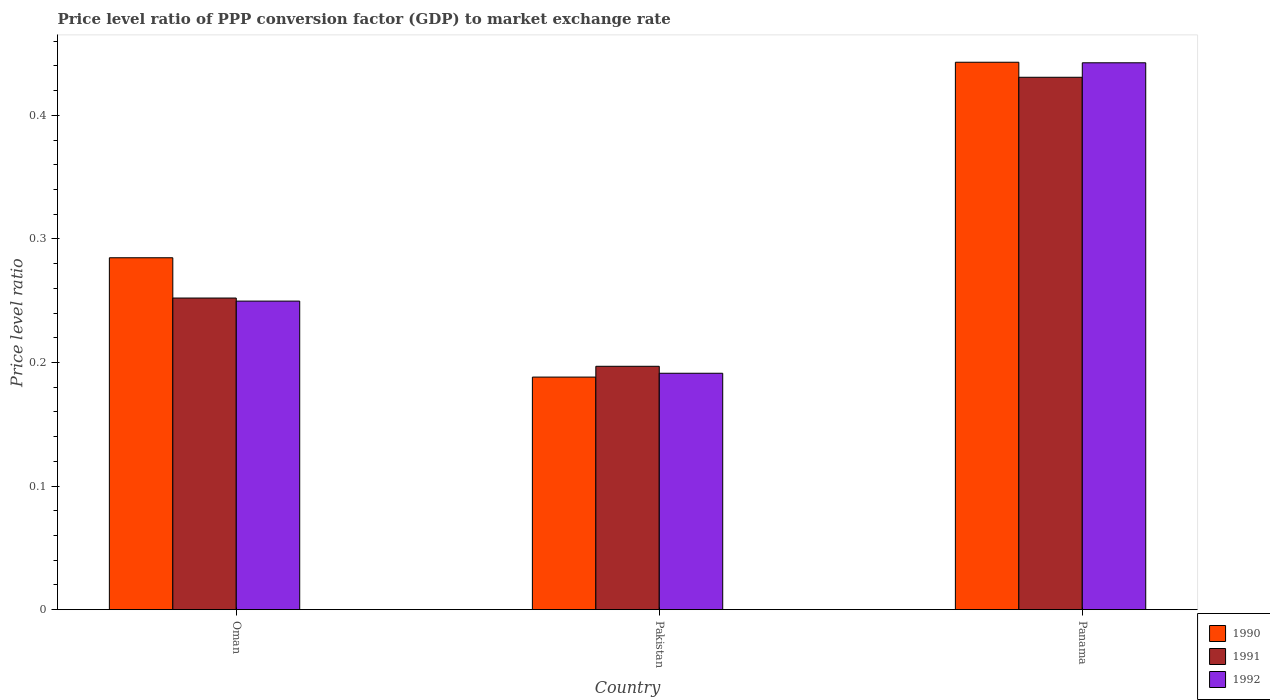How many different coloured bars are there?
Provide a short and direct response. 3. Are the number of bars per tick equal to the number of legend labels?
Make the answer very short. Yes. Are the number of bars on each tick of the X-axis equal?
Give a very brief answer. Yes. What is the label of the 2nd group of bars from the left?
Provide a short and direct response. Pakistan. What is the price level ratio in 1991 in Oman?
Your response must be concise. 0.25. Across all countries, what is the maximum price level ratio in 1992?
Your answer should be very brief. 0.44. Across all countries, what is the minimum price level ratio in 1990?
Make the answer very short. 0.19. In which country was the price level ratio in 1991 maximum?
Your answer should be compact. Panama. In which country was the price level ratio in 1990 minimum?
Provide a succinct answer. Pakistan. What is the total price level ratio in 1992 in the graph?
Offer a terse response. 0.88. What is the difference between the price level ratio in 1991 in Oman and that in Panama?
Your answer should be compact. -0.18. What is the difference between the price level ratio in 1990 in Oman and the price level ratio in 1992 in Pakistan?
Provide a short and direct response. 0.09. What is the average price level ratio in 1992 per country?
Your answer should be very brief. 0.29. What is the difference between the price level ratio of/in 1991 and price level ratio of/in 1990 in Panama?
Keep it short and to the point. -0.01. What is the ratio of the price level ratio in 1991 in Oman to that in Pakistan?
Keep it short and to the point. 1.28. Is the price level ratio in 1992 in Oman less than that in Panama?
Keep it short and to the point. Yes. What is the difference between the highest and the second highest price level ratio in 1992?
Your answer should be compact. 0.25. What is the difference between the highest and the lowest price level ratio in 1990?
Offer a very short reply. 0.25. In how many countries, is the price level ratio in 1992 greater than the average price level ratio in 1992 taken over all countries?
Keep it short and to the point. 1. What does the 3rd bar from the right in Pakistan represents?
Your answer should be very brief. 1990. Is it the case that in every country, the sum of the price level ratio in 1992 and price level ratio in 1991 is greater than the price level ratio in 1990?
Provide a succinct answer. Yes. Does the graph contain grids?
Ensure brevity in your answer.  No. How are the legend labels stacked?
Offer a very short reply. Vertical. What is the title of the graph?
Your response must be concise. Price level ratio of PPP conversion factor (GDP) to market exchange rate. Does "2009" appear as one of the legend labels in the graph?
Provide a succinct answer. No. What is the label or title of the Y-axis?
Make the answer very short. Price level ratio. What is the Price level ratio in 1990 in Oman?
Ensure brevity in your answer.  0.28. What is the Price level ratio of 1991 in Oman?
Your response must be concise. 0.25. What is the Price level ratio of 1992 in Oman?
Offer a terse response. 0.25. What is the Price level ratio in 1990 in Pakistan?
Your answer should be very brief. 0.19. What is the Price level ratio in 1991 in Pakistan?
Your answer should be very brief. 0.2. What is the Price level ratio in 1992 in Pakistan?
Give a very brief answer. 0.19. What is the Price level ratio of 1990 in Panama?
Keep it short and to the point. 0.44. What is the Price level ratio in 1991 in Panama?
Make the answer very short. 0.43. What is the Price level ratio of 1992 in Panama?
Give a very brief answer. 0.44. Across all countries, what is the maximum Price level ratio of 1990?
Your answer should be very brief. 0.44. Across all countries, what is the maximum Price level ratio of 1991?
Give a very brief answer. 0.43. Across all countries, what is the maximum Price level ratio of 1992?
Your response must be concise. 0.44. Across all countries, what is the minimum Price level ratio in 1990?
Your answer should be very brief. 0.19. Across all countries, what is the minimum Price level ratio in 1991?
Provide a short and direct response. 0.2. Across all countries, what is the minimum Price level ratio of 1992?
Keep it short and to the point. 0.19. What is the total Price level ratio in 1990 in the graph?
Provide a short and direct response. 0.92. What is the total Price level ratio of 1991 in the graph?
Provide a short and direct response. 0.88. What is the total Price level ratio in 1992 in the graph?
Offer a very short reply. 0.88. What is the difference between the Price level ratio in 1990 in Oman and that in Pakistan?
Your answer should be very brief. 0.1. What is the difference between the Price level ratio of 1991 in Oman and that in Pakistan?
Make the answer very short. 0.06. What is the difference between the Price level ratio of 1992 in Oman and that in Pakistan?
Your answer should be compact. 0.06. What is the difference between the Price level ratio of 1990 in Oman and that in Panama?
Make the answer very short. -0.16. What is the difference between the Price level ratio of 1991 in Oman and that in Panama?
Make the answer very short. -0.18. What is the difference between the Price level ratio in 1992 in Oman and that in Panama?
Ensure brevity in your answer.  -0.19. What is the difference between the Price level ratio in 1990 in Pakistan and that in Panama?
Ensure brevity in your answer.  -0.25. What is the difference between the Price level ratio in 1991 in Pakistan and that in Panama?
Your response must be concise. -0.23. What is the difference between the Price level ratio in 1992 in Pakistan and that in Panama?
Give a very brief answer. -0.25. What is the difference between the Price level ratio in 1990 in Oman and the Price level ratio in 1991 in Pakistan?
Provide a succinct answer. 0.09. What is the difference between the Price level ratio in 1990 in Oman and the Price level ratio in 1992 in Pakistan?
Provide a succinct answer. 0.09. What is the difference between the Price level ratio in 1991 in Oman and the Price level ratio in 1992 in Pakistan?
Give a very brief answer. 0.06. What is the difference between the Price level ratio of 1990 in Oman and the Price level ratio of 1991 in Panama?
Give a very brief answer. -0.15. What is the difference between the Price level ratio of 1990 in Oman and the Price level ratio of 1992 in Panama?
Your response must be concise. -0.16. What is the difference between the Price level ratio in 1991 in Oman and the Price level ratio in 1992 in Panama?
Offer a terse response. -0.19. What is the difference between the Price level ratio of 1990 in Pakistan and the Price level ratio of 1991 in Panama?
Provide a succinct answer. -0.24. What is the difference between the Price level ratio in 1990 in Pakistan and the Price level ratio in 1992 in Panama?
Keep it short and to the point. -0.25. What is the difference between the Price level ratio in 1991 in Pakistan and the Price level ratio in 1992 in Panama?
Your answer should be very brief. -0.25. What is the average Price level ratio in 1990 per country?
Provide a short and direct response. 0.31. What is the average Price level ratio of 1991 per country?
Your answer should be very brief. 0.29. What is the average Price level ratio in 1992 per country?
Your answer should be very brief. 0.29. What is the difference between the Price level ratio in 1990 and Price level ratio in 1991 in Oman?
Offer a terse response. 0.03. What is the difference between the Price level ratio of 1990 and Price level ratio of 1992 in Oman?
Ensure brevity in your answer.  0.04. What is the difference between the Price level ratio of 1991 and Price level ratio of 1992 in Oman?
Your response must be concise. 0. What is the difference between the Price level ratio of 1990 and Price level ratio of 1991 in Pakistan?
Keep it short and to the point. -0.01. What is the difference between the Price level ratio in 1990 and Price level ratio in 1992 in Pakistan?
Provide a succinct answer. -0. What is the difference between the Price level ratio of 1991 and Price level ratio of 1992 in Pakistan?
Give a very brief answer. 0.01. What is the difference between the Price level ratio in 1990 and Price level ratio in 1991 in Panama?
Make the answer very short. 0.01. What is the difference between the Price level ratio of 1990 and Price level ratio of 1992 in Panama?
Make the answer very short. 0. What is the difference between the Price level ratio of 1991 and Price level ratio of 1992 in Panama?
Your answer should be very brief. -0.01. What is the ratio of the Price level ratio in 1990 in Oman to that in Pakistan?
Your answer should be very brief. 1.51. What is the ratio of the Price level ratio of 1991 in Oman to that in Pakistan?
Your answer should be compact. 1.28. What is the ratio of the Price level ratio in 1992 in Oman to that in Pakistan?
Keep it short and to the point. 1.31. What is the ratio of the Price level ratio of 1990 in Oman to that in Panama?
Your response must be concise. 0.64. What is the ratio of the Price level ratio of 1991 in Oman to that in Panama?
Your answer should be very brief. 0.59. What is the ratio of the Price level ratio in 1992 in Oman to that in Panama?
Your answer should be compact. 0.56. What is the ratio of the Price level ratio in 1990 in Pakistan to that in Panama?
Keep it short and to the point. 0.42. What is the ratio of the Price level ratio in 1991 in Pakistan to that in Panama?
Provide a succinct answer. 0.46. What is the ratio of the Price level ratio of 1992 in Pakistan to that in Panama?
Give a very brief answer. 0.43. What is the difference between the highest and the second highest Price level ratio in 1990?
Your answer should be very brief. 0.16. What is the difference between the highest and the second highest Price level ratio of 1991?
Provide a succinct answer. 0.18. What is the difference between the highest and the second highest Price level ratio in 1992?
Offer a very short reply. 0.19. What is the difference between the highest and the lowest Price level ratio of 1990?
Keep it short and to the point. 0.25. What is the difference between the highest and the lowest Price level ratio of 1991?
Offer a terse response. 0.23. What is the difference between the highest and the lowest Price level ratio in 1992?
Give a very brief answer. 0.25. 